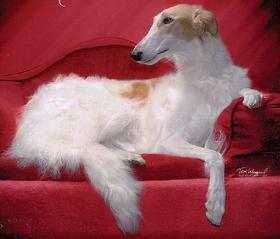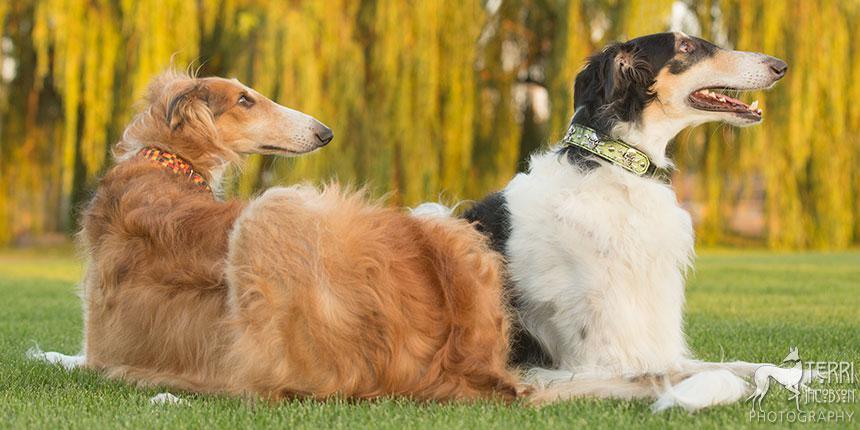The first image is the image on the left, the second image is the image on the right. For the images displayed, is the sentence "There are three dogs." factually correct? Answer yes or no. Yes. The first image is the image on the left, the second image is the image on the right. Considering the images on both sides, is "A single dog is lying down in the image on the right." valid? Answer yes or no. No. 